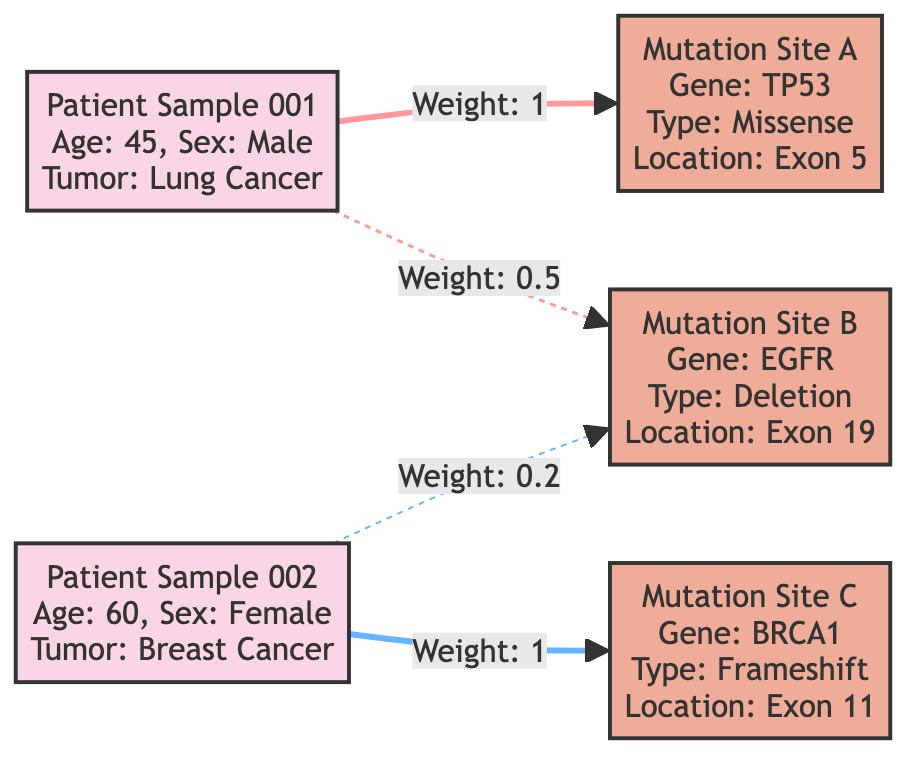What is the age of Patient Sample 001? The node representing Patient Sample 001 indicates that the age is listed as 45.
Answer: 45 What mutation type is associated with Mutation Site A? The node for Mutation Site A specifies that the mutation type is Missense, which is provided in the attributes section of the node.
Answer: Missense How many patient samples are represented in the diagram? By examining the nodes, there are two distinct patient samples present: Patient Sample 001 and Patient Sample 002.
Answer: 2 What is the weight of the edge connecting Patient Sample 002 to Mutation Site C? The edge connecting Patient Sample 002 to Mutation Site C has a specified weight of 1, as indicated directly on the edge in the diagram.
Answer: 1 Which mutation site is associated with the highest weight for Patient Sample 001? Analyzing the edges from Patient Sample 001, the edge to Mutation Site A has the highest weight of 1 compared to the 0.5 to Mutation Site B.
Answer: Mutation Site A What is the relationship between Patient Sample 002 and Mutation Site B? The diagram presents a dashed edge from Patient Sample 002 to Mutation Site B with a weight of 0.2, indicating a weaker association compared to the other edges.
Answer: Weak association What gene is linked to Mutation Site C? Reviewing the details of Mutation Site C, the gene associated with it is BRCA1, which is specified in the attributes of the node.
Answer: BRCA1 How many mutations are associated with Patient Sample 001? Analyzing the edges, Patient Sample 001 is associated with two mutations – Mutation Site A and Mutation Site B.
Answer: 2 Which patient sample does not have an association with Mutation Site C? By looking at the edge connections, Patient Sample 001 does not have a direct edge connecting it to Mutation Site C, which is only connected to Patient Sample 002.
Answer: Patient Sample 001 What type of mutation is found at Mutation Site B? Mutation Site B is identified as having a Deletion mutation type in the attributes section of the node.
Answer: Deletion 